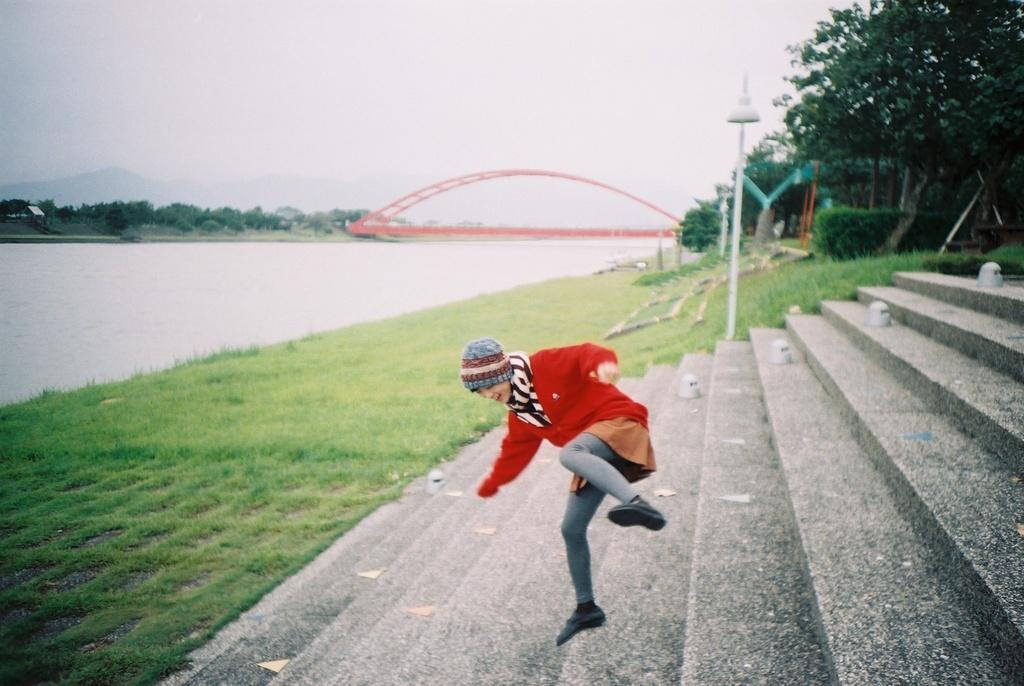What is the person in the image doing? The person in the image is in motion, which suggests they might be walking or running. What architectural feature can be seen in the image? There are steps in the image. What type of natural environment is visible in the image? There is grass, plants, trees, and water in the image, which suggests a park or garden setting. What is the source of light in the image? There is a light pole in the image, which is likely the source of light. What is visible in the background of the image? The sky is visible in the background of the image. What type of destruction can be seen in the image? There is no destruction present in the image; it features a person in motion, steps, grass, water, plants, trees, and a light pole in a natural setting. What type of wax is visible in the image? There is no wax present in the image. 